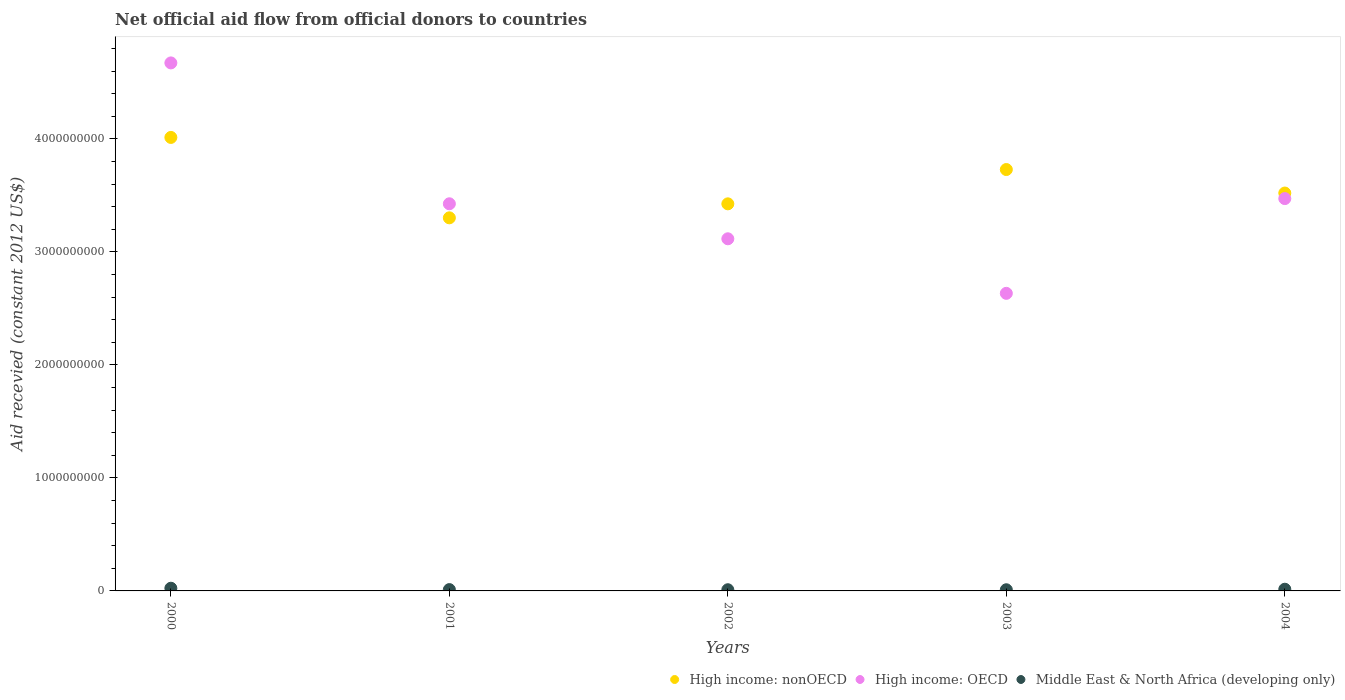How many different coloured dotlines are there?
Your answer should be compact. 3. What is the total aid received in Middle East & North Africa (developing only) in 2004?
Your answer should be very brief. 1.50e+07. Across all years, what is the maximum total aid received in High income: nonOECD?
Offer a terse response. 4.01e+09. Across all years, what is the minimum total aid received in High income: nonOECD?
Your answer should be very brief. 3.30e+09. In which year was the total aid received in High income: OECD minimum?
Keep it short and to the point. 2003. What is the total total aid received in High income: OECD in the graph?
Your answer should be very brief. 1.73e+1. What is the difference between the total aid received in Middle East & North Africa (developing only) in 2000 and that in 2004?
Provide a short and direct response. 8.78e+06. What is the difference between the total aid received in High income: OECD in 2002 and the total aid received in High income: nonOECD in 2003?
Provide a short and direct response. -6.13e+08. What is the average total aid received in Middle East & North Africa (developing only) per year?
Offer a terse response. 1.43e+07. In the year 2004, what is the difference between the total aid received in High income: nonOECD and total aid received in Middle East & North Africa (developing only)?
Your answer should be very brief. 3.51e+09. What is the ratio of the total aid received in High income: nonOECD in 2002 to that in 2003?
Make the answer very short. 0.92. Is the total aid received in Middle East & North Africa (developing only) in 2001 less than that in 2002?
Provide a short and direct response. No. Is the difference between the total aid received in High income: nonOECD in 2001 and 2003 greater than the difference between the total aid received in Middle East & North Africa (developing only) in 2001 and 2003?
Give a very brief answer. No. What is the difference between the highest and the second highest total aid received in High income: nonOECD?
Make the answer very short. 2.84e+08. What is the difference between the highest and the lowest total aid received in High income: nonOECD?
Keep it short and to the point. 7.12e+08. In how many years, is the total aid received in High income: OECD greater than the average total aid received in High income: OECD taken over all years?
Your answer should be compact. 2. Is the sum of the total aid received in High income: OECD in 2001 and 2003 greater than the maximum total aid received in High income: nonOECD across all years?
Ensure brevity in your answer.  Yes. Is the total aid received in High income: OECD strictly greater than the total aid received in High income: nonOECD over the years?
Offer a very short reply. No. How many dotlines are there?
Your response must be concise. 3. Does the graph contain grids?
Offer a terse response. No. How are the legend labels stacked?
Provide a succinct answer. Horizontal. What is the title of the graph?
Ensure brevity in your answer.  Net official aid flow from official donors to countries. What is the label or title of the X-axis?
Your answer should be compact. Years. What is the label or title of the Y-axis?
Offer a terse response. Aid recevied (constant 2012 US$). What is the Aid recevied (constant 2012 US$) in High income: nonOECD in 2000?
Provide a short and direct response. 4.01e+09. What is the Aid recevied (constant 2012 US$) of High income: OECD in 2000?
Offer a terse response. 4.67e+09. What is the Aid recevied (constant 2012 US$) of Middle East & North Africa (developing only) in 2000?
Your answer should be very brief. 2.38e+07. What is the Aid recevied (constant 2012 US$) in High income: nonOECD in 2001?
Ensure brevity in your answer.  3.30e+09. What is the Aid recevied (constant 2012 US$) of High income: OECD in 2001?
Offer a terse response. 3.43e+09. What is the Aid recevied (constant 2012 US$) in Middle East & North Africa (developing only) in 2001?
Ensure brevity in your answer.  1.17e+07. What is the Aid recevied (constant 2012 US$) in High income: nonOECD in 2002?
Your response must be concise. 3.43e+09. What is the Aid recevied (constant 2012 US$) in High income: OECD in 2002?
Make the answer very short. 3.12e+09. What is the Aid recevied (constant 2012 US$) of Middle East & North Africa (developing only) in 2002?
Offer a very short reply. 1.05e+07. What is the Aid recevied (constant 2012 US$) in High income: nonOECD in 2003?
Give a very brief answer. 3.73e+09. What is the Aid recevied (constant 2012 US$) in High income: OECD in 2003?
Provide a short and direct response. 2.63e+09. What is the Aid recevied (constant 2012 US$) in Middle East & North Africa (developing only) in 2003?
Your answer should be very brief. 1.03e+07. What is the Aid recevied (constant 2012 US$) of High income: nonOECD in 2004?
Give a very brief answer. 3.52e+09. What is the Aid recevied (constant 2012 US$) in High income: OECD in 2004?
Give a very brief answer. 3.47e+09. What is the Aid recevied (constant 2012 US$) in Middle East & North Africa (developing only) in 2004?
Make the answer very short. 1.50e+07. Across all years, what is the maximum Aid recevied (constant 2012 US$) of High income: nonOECD?
Provide a short and direct response. 4.01e+09. Across all years, what is the maximum Aid recevied (constant 2012 US$) of High income: OECD?
Keep it short and to the point. 4.67e+09. Across all years, what is the maximum Aid recevied (constant 2012 US$) of Middle East & North Africa (developing only)?
Give a very brief answer. 2.38e+07. Across all years, what is the minimum Aid recevied (constant 2012 US$) of High income: nonOECD?
Offer a very short reply. 3.30e+09. Across all years, what is the minimum Aid recevied (constant 2012 US$) of High income: OECD?
Offer a very short reply. 2.63e+09. Across all years, what is the minimum Aid recevied (constant 2012 US$) in Middle East & North Africa (developing only)?
Provide a succinct answer. 1.03e+07. What is the total Aid recevied (constant 2012 US$) in High income: nonOECD in the graph?
Give a very brief answer. 1.80e+1. What is the total Aid recevied (constant 2012 US$) in High income: OECD in the graph?
Keep it short and to the point. 1.73e+1. What is the total Aid recevied (constant 2012 US$) in Middle East & North Africa (developing only) in the graph?
Give a very brief answer. 7.14e+07. What is the difference between the Aid recevied (constant 2012 US$) in High income: nonOECD in 2000 and that in 2001?
Provide a succinct answer. 7.12e+08. What is the difference between the Aid recevied (constant 2012 US$) in High income: OECD in 2000 and that in 2001?
Offer a terse response. 1.25e+09. What is the difference between the Aid recevied (constant 2012 US$) in Middle East & North Africa (developing only) in 2000 and that in 2001?
Provide a short and direct response. 1.21e+07. What is the difference between the Aid recevied (constant 2012 US$) of High income: nonOECD in 2000 and that in 2002?
Offer a terse response. 5.88e+08. What is the difference between the Aid recevied (constant 2012 US$) of High income: OECD in 2000 and that in 2002?
Ensure brevity in your answer.  1.56e+09. What is the difference between the Aid recevied (constant 2012 US$) in Middle East & North Africa (developing only) in 2000 and that in 2002?
Keep it short and to the point. 1.33e+07. What is the difference between the Aid recevied (constant 2012 US$) in High income: nonOECD in 2000 and that in 2003?
Give a very brief answer. 2.84e+08. What is the difference between the Aid recevied (constant 2012 US$) in High income: OECD in 2000 and that in 2003?
Ensure brevity in your answer.  2.04e+09. What is the difference between the Aid recevied (constant 2012 US$) in Middle East & North Africa (developing only) in 2000 and that in 2003?
Your response must be concise. 1.34e+07. What is the difference between the Aid recevied (constant 2012 US$) in High income: nonOECD in 2000 and that in 2004?
Your answer should be very brief. 4.92e+08. What is the difference between the Aid recevied (constant 2012 US$) of High income: OECD in 2000 and that in 2004?
Your answer should be very brief. 1.20e+09. What is the difference between the Aid recevied (constant 2012 US$) in Middle East & North Africa (developing only) in 2000 and that in 2004?
Keep it short and to the point. 8.78e+06. What is the difference between the Aid recevied (constant 2012 US$) in High income: nonOECD in 2001 and that in 2002?
Your answer should be compact. -1.24e+08. What is the difference between the Aid recevied (constant 2012 US$) of High income: OECD in 2001 and that in 2002?
Your response must be concise. 3.10e+08. What is the difference between the Aid recevied (constant 2012 US$) in Middle East & North Africa (developing only) in 2001 and that in 2002?
Provide a short and direct response. 1.22e+06. What is the difference between the Aid recevied (constant 2012 US$) in High income: nonOECD in 2001 and that in 2003?
Make the answer very short. -4.27e+08. What is the difference between the Aid recevied (constant 2012 US$) in High income: OECD in 2001 and that in 2003?
Your response must be concise. 7.93e+08. What is the difference between the Aid recevied (constant 2012 US$) of Middle East & North Africa (developing only) in 2001 and that in 2003?
Provide a succinct answer. 1.39e+06. What is the difference between the Aid recevied (constant 2012 US$) in High income: nonOECD in 2001 and that in 2004?
Your answer should be very brief. -2.19e+08. What is the difference between the Aid recevied (constant 2012 US$) of High income: OECD in 2001 and that in 2004?
Provide a succinct answer. -4.60e+07. What is the difference between the Aid recevied (constant 2012 US$) in Middle East & North Africa (developing only) in 2001 and that in 2004?
Offer a very short reply. -3.28e+06. What is the difference between the Aid recevied (constant 2012 US$) in High income: nonOECD in 2002 and that in 2003?
Give a very brief answer. -3.04e+08. What is the difference between the Aid recevied (constant 2012 US$) of High income: OECD in 2002 and that in 2003?
Your answer should be very brief. 4.83e+08. What is the difference between the Aid recevied (constant 2012 US$) of Middle East & North Africa (developing only) in 2002 and that in 2003?
Your answer should be very brief. 1.70e+05. What is the difference between the Aid recevied (constant 2012 US$) in High income: nonOECD in 2002 and that in 2004?
Your answer should be very brief. -9.56e+07. What is the difference between the Aid recevied (constant 2012 US$) of High income: OECD in 2002 and that in 2004?
Provide a short and direct response. -3.56e+08. What is the difference between the Aid recevied (constant 2012 US$) in Middle East & North Africa (developing only) in 2002 and that in 2004?
Provide a short and direct response. -4.50e+06. What is the difference between the Aid recevied (constant 2012 US$) in High income: nonOECD in 2003 and that in 2004?
Offer a terse response. 2.08e+08. What is the difference between the Aid recevied (constant 2012 US$) of High income: OECD in 2003 and that in 2004?
Provide a succinct answer. -8.39e+08. What is the difference between the Aid recevied (constant 2012 US$) of Middle East & North Africa (developing only) in 2003 and that in 2004?
Ensure brevity in your answer.  -4.67e+06. What is the difference between the Aid recevied (constant 2012 US$) in High income: nonOECD in 2000 and the Aid recevied (constant 2012 US$) in High income: OECD in 2001?
Keep it short and to the point. 5.87e+08. What is the difference between the Aid recevied (constant 2012 US$) of High income: nonOECD in 2000 and the Aid recevied (constant 2012 US$) of Middle East & North Africa (developing only) in 2001?
Your answer should be very brief. 4.00e+09. What is the difference between the Aid recevied (constant 2012 US$) of High income: OECD in 2000 and the Aid recevied (constant 2012 US$) of Middle East & North Africa (developing only) in 2001?
Your answer should be compact. 4.66e+09. What is the difference between the Aid recevied (constant 2012 US$) of High income: nonOECD in 2000 and the Aid recevied (constant 2012 US$) of High income: OECD in 2002?
Your answer should be compact. 8.97e+08. What is the difference between the Aid recevied (constant 2012 US$) of High income: nonOECD in 2000 and the Aid recevied (constant 2012 US$) of Middle East & North Africa (developing only) in 2002?
Give a very brief answer. 4.00e+09. What is the difference between the Aid recevied (constant 2012 US$) in High income: OECD in 2000 and the Aid recevied (constant 2012 US$) in Middle East & North Africa (developing only) in 2002?
Your answer should be very brief. 4.66e+09. What is the difference between the Aid recevied (constant 2012 US$) in High income: nonOECD in 2000 and the Aid recevied (constant 2012 US$) in High income: OECD in 2003?
Provide a short and direct response. 1.38e+09. What is the difference between the Aid recevied (constant 2012 US$) in High income: nonOECD in 2000 and the Aid recevied (constant 2012 US$) in Middle East & North Africa (developing only) in 2003?
Keep it short and to the point. 4.00e+09. What is the difference between the Aid recevied (constant 2012 US$) of High income: OECD in 2000 and the Aid recevied (constant 2012 US$) of Middle East & North Africa (developing only) in 2003?
Provide a succinct answer. 4.66e+09. What is the difference between the Aid recevied (constant 2012 US$) in High income: nonOECD in 2000 and the Aid recevied (constant 2012 US$) in High income: OECD in 2004?
Your answer should be very brief. 5.41e+08. What is the difference between the Aid recevied (constant 2012 US$) in High income: nonOECD in 2000 and the Aid recevied (constant 2012 US$) in Middle East & North Africa (developing only) in 2004?
Your answer should be compact. 4.00e+09. What is the difference between the Aid recevied (constant 2012 US$) of High income: OECD in 2000 and the Aid recevied (constant 2012 US$) of Middle East & North Africa (developing only) in 2004?
Your answer should be very brief. 4.66e+09. What is the difference between the Aid recevied (constant 2012 US$) of High income: nonOECD in 2001 and the Aid recevied (constant 2012 US$) of High income: OECD in 2002?
Provide a short and direct response. 1.85e+08. What is the difference between the Aid recevied (constant 2012 US$) of High income: nonOECD in 2001 and the Aid recevied (constant 2012 US$) of Middle East & North Africa (developing only) in 2002?
Ensure brevity in your answer.  3.29e+09. What is the difference between the Aid recevied (constant 2012 US$) of High income: OECD in 2001 and the Aid recevied (constant 2012 US$) of Middle East & North Africa (developing only) in 2002?
Offer a terse response. 3.42e+09. What is the difference between the Aid recevied (constant 2012 US$) in High income: nonOECD in 2001 and the Aid recevied (constant 2012 US$) in High income: OECD in 2003?
Provide a short and direct response. 6.68e+08. What is the difference between the Aid recevied (constant 2012 US$) of High income: nonOECD in 2001 and the Aid recevied (constant 2012 US$) of Middle East & North Africa (developing only) in 2003?
Provide a short and direct response. 3.29e+09. What is the difference between the Aid recevied (constant 2012 US$) of High income: OECD in 2001 and the Aid recevied (constant 2012 US$) of Middle East & North Africa (developing only) in 2003?
Give a very brief answer. 3.42e+09. What is the difference between the Aid recevied (constant 2012 US$) in High income: nonOECD in 2001 and the Aid recevied (constant 2012 US$) in High income: OECD in 2004?
Your response must be concise. -1.70e+08. What is the difference between the Aid recevied (constant 2012 US$) in High income: nonOECD in 2001 and the Aid recevied (constant 2012 US$) in Middle East & North Africa (developing only) in 2004?
Provide a short and direct response. 3.29e+09. What is the difference between the Aid recevied (constant 2012 US$) of High income: OECD in 2001 and the Aid recevied (constant 2012 US$) of Middle East & North Africa (developing only) in 2004?
Offer a very short reply. 3.41e+09. What is the difference between the Aid recevied (constant 2012 US$) of High income: nonOECD in 2002 and the Aid recevied (constant 2012 US$) of High income: OECD in 2003?
Give a very brief answer. 7.92e+08. What is the difference between the Aid recevied (constant 2012 US$) of High income: nonOECD in 2002 and the Aid recevied (constant 2012 US$) of Middle East & North Africa (developing only) in 2003?
Make the answer very short. 3.42e+09. What is the difference between the Aid recevied (constant 2012 US$) in High income: OECD in 2002 and the Aid recevied (constant 2012 US$) in Middle East & North Africa (developing only) in 2003?
Make the answer very short. 3.11e+09. What is the difference between the Aid recevied (constant 2012 US$) in High income: nonOECD in 2002 and the Aid recevied (constant 2012 US$) in High income: OECD in 2004?
Make the answer very short. -4.65e+07. What is the difference between the Aid recevied (constant 2012 US$) of High income: nonOECD in 2002 and the Aid recevied (constant 2012 US$) of Middle East & North Africa (developing only) in 2004?
Your response must be concise. 3.41e+09. What is the difference between the Aid recevied (constant 2012 US$) of High income: OECD in 2002 and the Aid recevied (constant 2012 US$) of Middle East & North Africa (developing only) in 2004?
Provide a succinct answer. 3.10e+09. What is the difference between the Aid recevied (constant 2012 US$) of High income: nonOECD in 2003 and the Aid recevied (constant 2012 US$) of High income: OECD in 2004?
Offer a very short reply. 2.57e+08. What is the difference between the Aid recevied (constant 2012 US$) of High income: nonOECD in 2003 and the Aid recevied (constant 2012 US$) of Middle East & North Africa (developing only) in 2004?
Your response must be concise. 3.71e+09. What is the difference between the Aid recevied (constant 2012 US$) of High income: OECD in 2003 and the Aid recevied (constant 2012 US$) of Middle East & North Africa (developing only) in 2004?
Make the answer very short. 2.62e+09. What is the average Aid recevied (constant 2012 US$) in High income: nonOECD per year?
Offer a terse response. 3.60e+09. What is the average Aid recevied (constant 2012 US$) of High income: OECD per year?
Keep it short and to the point. 3.46e+09. What is the average Aid recevied (constant 2012 US$) of Middle East & North Africa (developing only) per year?
Provide a succinct answer. 1.43e+07. In the year 2000, what is the difference between the Aid recevied (constant 2012 US$) of High income: nonOECD and Aid recevied (constant 2012 US$) of High income: OECD?
Offer a very short reply. -6.59e+08. In the year 2000, what is the difference between the Aid recevied (constant 2012 US$) of High income: nonOECD and Aid recevied (constant 2012 US$) of Middle East & North Africa (developing only)?
Ensure brevity in your answer.  3.99e+09. In the year 2000, what is the difference between the Aid recevied (constant 2012 US$) in High income: OECD and Aid recevied (constant 2012 US$) in Middle East & North Africa (developing only)?
Your answer should be very brief. 4.65e+09. In the year 2001, what is the difference between the Aid recevied (constant 2012 US$) in High income: nonOECD and Aid recevied (constant 2012 US$) in High income: OECD?
Your response must be concise. -1.24e+08. In the year 2001, what is the difference between the Aid recevied (constant 2012 US$) in High income: nonOECD and Aid recevied (constant 2012 US$) in Middle East & North Africa (developing only)?
Your answer should be very brief. 3.29e+09. In the year 2001, what is the difference between the Aid recevied (constant 2012 US$) of High income: OECD and Aid recevied (constant 2012 US$) of Middle East & North Africa (developing only)?
Provide a short and direct response. 3.41e+09. In the year 2002, what is the difference between the Aid recevied (constant 2012 US$) of High income: nonOECD and Aid recevied (constant 2012 US$) of High income: OECD?
Offer a very short reply. 3.09e+08. In the year 2002, what is the difference between the Aid recevied (constant 2012 US$) in High income: nonOECD and Aid recevied (constant 2012 US$) in Middle East & North Africa (developing only)?
Offer a very short reply. 3.42e+09. In the year 2002, what is the difference between the Aid recevied (constant 2012 US$) in High income: OECD and Aid recevied (constant 2012 US$) in Middle East & North Africa (developing only)?
Provide a succinct answer. 3.11e+09. In the year 2003, what is the difference between the Aid recevied (constant 2012 US$) in High income: nonOECD and Aid recevied (constant 2012 US$) in High income: OECD?
Provide a succinct answer. 1.10e+09. In the year 2003, what is the difference between the Aid recevied (constant 2012 US$) in High income: nonOECD and Aid recevied (constant 2012 US$) in Middle East & North Africa (developing only)?
Your answer should be very brief. 3.72e+09. In the year 2003, what is the difference between the Aid recevied (constant 2012 US$) of High income: OECD and Aid recevied (constant 2012 US$) of Middle East & North Africa (developing only)?
Your answer should be compact. 2.62e+09. In the year 2004, what is the difference between the Aid recevied (constant 2012 US$) of High income: nonOECD and Aid recevied (constant 2012 US$) of High income: OECD?
Your answer should be compact. 4.91e+07. In the year 2004, what is the difference between the Aid recevied (constant 2012 US$) in High income: nonOECD and Aid recevied (constant 2012 US$) in Middle East & North Africa (developing only)?
Keep it short and to the point. 3.51e+09. In the year 2004, what is the difference between the Aid recevied (constant 2012 US$) of High income: OECD and Aid recevied (constant 2012 US$) of Middle East & North Africa (developing only)?
Your answer should be compact. 3.46e+09. What is the ratio of the Aid recevied (constant 2012 US$) in High income: nonOECD in 2000 to that in 2001?
Offer a very short reply. 1.22. What is the ratio of the Aid recevied (constant 2012 US$) of High income: OECD in 2000 to that in 2001?
Your answer should be compact. 1.36. What is the ratio of the Aid recevied (constant 2012 US$) of Middle East & North Africa (developing only) in 2000 to that in 2001?
Provide a short and direct response. 2.03. What is the ratio of the Aid recevied (constant 2012 US$) in High income: nonOECD in 2000 to that in 2002?
Provide a succinct answer. 1.17. What is the ratio of the Aid recevied (constant 2012 US$) of High income: OECD in 2000 to that in 2002?
Provide a succinct answer. 1.5. What is the ratio of the Aid recevied (constant 2012 US$) of Middle East & North Africa (developing only) in 2000 to that in 2002?
Your answer should be very brief. 2.26. What is the ratio of the Aid recevied (constant 2012 US$) of High income: nonOECD in 2000 to that in 2003?
Keep it short and to the point. 1.08. What is the ratio of the Aid recevied (constant 2012 US$) in High income: OECD in 2000 to that in 2003?
Ensure brevity in your answer.  1.77. What is the ratio of the Aid recevied (constant 2012 US$) in Middle East & North Africa (developing only) in 2000 to that in 2003?
Your answer should be very brief. 2.3. What is the ratio of the Aid recevied (constant 2012 US$) of High income: nonOECD in 2000 to that in 2004?
Provide a short and direct response. 1.14. What is the ratio of the Aid recevied (constant 2012 US$) of High income: OECD in 2000 to that in 2004?
Your response must be concise. 1.35. What is the ratio of the Aid recevied (constant 2012 US$) of Middle East & North Africa (developing only) in 2000 to that in 2004?
Give a very brief answer. 1.58. What is the ratio of the Aid recevied (constant 2012 US$) in High income: nonOECD in 2001 to that in 2002?
Your answer should be very brief. 0.96. What is the ratio of the Aid recevied (constant 2012 US$) in High income: OECD in 2001 to that in 2002?
Provide a succinct answer. 1.1. What is the ratio of the Aid recevied (constant 2012 US$) of Middle East & North Africa (developing only) in 2001 to that in 2002?
Your answer should be very brief. 1.12. What is the ratio of the Aid recevied (constant 2012 US$) of High income: nonOECD in 2001 to that in 2003?
Provide a succinct answer. 0.89. What is the ratio of the Aid recevied (constant 2012 US$) in High income: OECD in 2001 to that in 2003?
Make the answer very short. 1.3. What is the ratio of the Aid recevied (constant 2012 US$) in Middle East & North Africa (developing only) in 2001 to that in 2003?
Give a very brief answer. 1.13. What is the ratio of the Aid recevied (constant 2012 US$) in High income: nonOECD in 2001 to that in 2004?
Your answer should be very brief. 0.94. What is the ratio of the Aid recevied (constant 2012 US$) in High income: OECD in 2001 to that in 2004?
Offer a terse response. 0.99. What is the ratio of the Aid recevied (constant 2012 US$) in Middle East & North Africa (developing only) in 2001 to that in 2004?
Offer a very short reply. 0.78. What is the ratio of the Aid recevied (constant 2012 US$) of High income: nonOECD in 2002 to that in 2003?
Give a very brief answer. 0.92. What is the ratio of the Aid recevied (constant 2012 US$) of High income: OECD in 2002 to that in 2003?
Ensure brevity in your answer.  1.18. What is the ratio of the Aid recevied (constant 2012 US$) of Middle East & North Africa (developing only) in 2002 to that in 2003?
Give a very brief answer. 1.02. What is the ratio of the Aid recevied (constant 2012 US$) in High income: nonOECD in 2002 to that in 2004?
Provide a succinct answer. 0.97. What is the ratio of the Aid recevied (constant 2012 US$) in High income: OECD in 2002 to that in 2004?
Your answer should be compact. 0.9. What is the ratio of the Aid recevied (constant 2012 US$) in Middle East & North Africa (developing only) in 2002 to that in 2004?
Make the answer very short. 0.7. What is the ratio of the Aid recevied (constant 2012 US$) of High income: nonOECD in 2003 to that in 2004?
Your answer should be very brief. 1.06. What is the ratio of the Aid recevied (constant 2012 US$) in High income: OECD in 2003 to that in 2004?
Provide a short and direct response. 0.76. What is the ratio of the Aid recevied (constant 2012 US$) of Middle East & North Africa (developing only) in 2003 to that in 2004?
Give a very brief answer. 0.69. What is the difference between the highest and the second highest Aid recevied (constant 2012 US$) of High income: nonOECD?
Offer a terse response. 2.84e+08. What is the difference between the highest and the second highest Aid recevied (constant 2012 US$) of High income: OECD?
Give a very brief answer. 1.20e+09. What is the difference between the highest and the second highest Aid recevied (constant 2012 US$) of Middle East & North Africa (developing only)?
Your response must be concise. 8.78e+06. What is the difference between the highest and the lowest Aid recevied (constant 2012 US$) of High income: nonOECD?
Make the answer very short. 7.12e+08. What is the difference between the highest and the lowest Aid recevied (constant 2012 US$) in High income: OECD?
Offer a very short reply. 2.04e+09. What is the difference between the highest and the lowest Aid recevied (constant 2012 US$) of Middle East & North Africa (developing only)?
Your answer should be compact. 1.34e+07. 